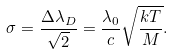<formula> <loc_0><loc_0><loc_500><loc_500>\sigma = \frac { \Delta \lambda _ { D } } { \sqrt { 2 } } = \frac { \lambda _ { 0 } } { c } \sqrt { \frac { k T } { M } } .</formula> 